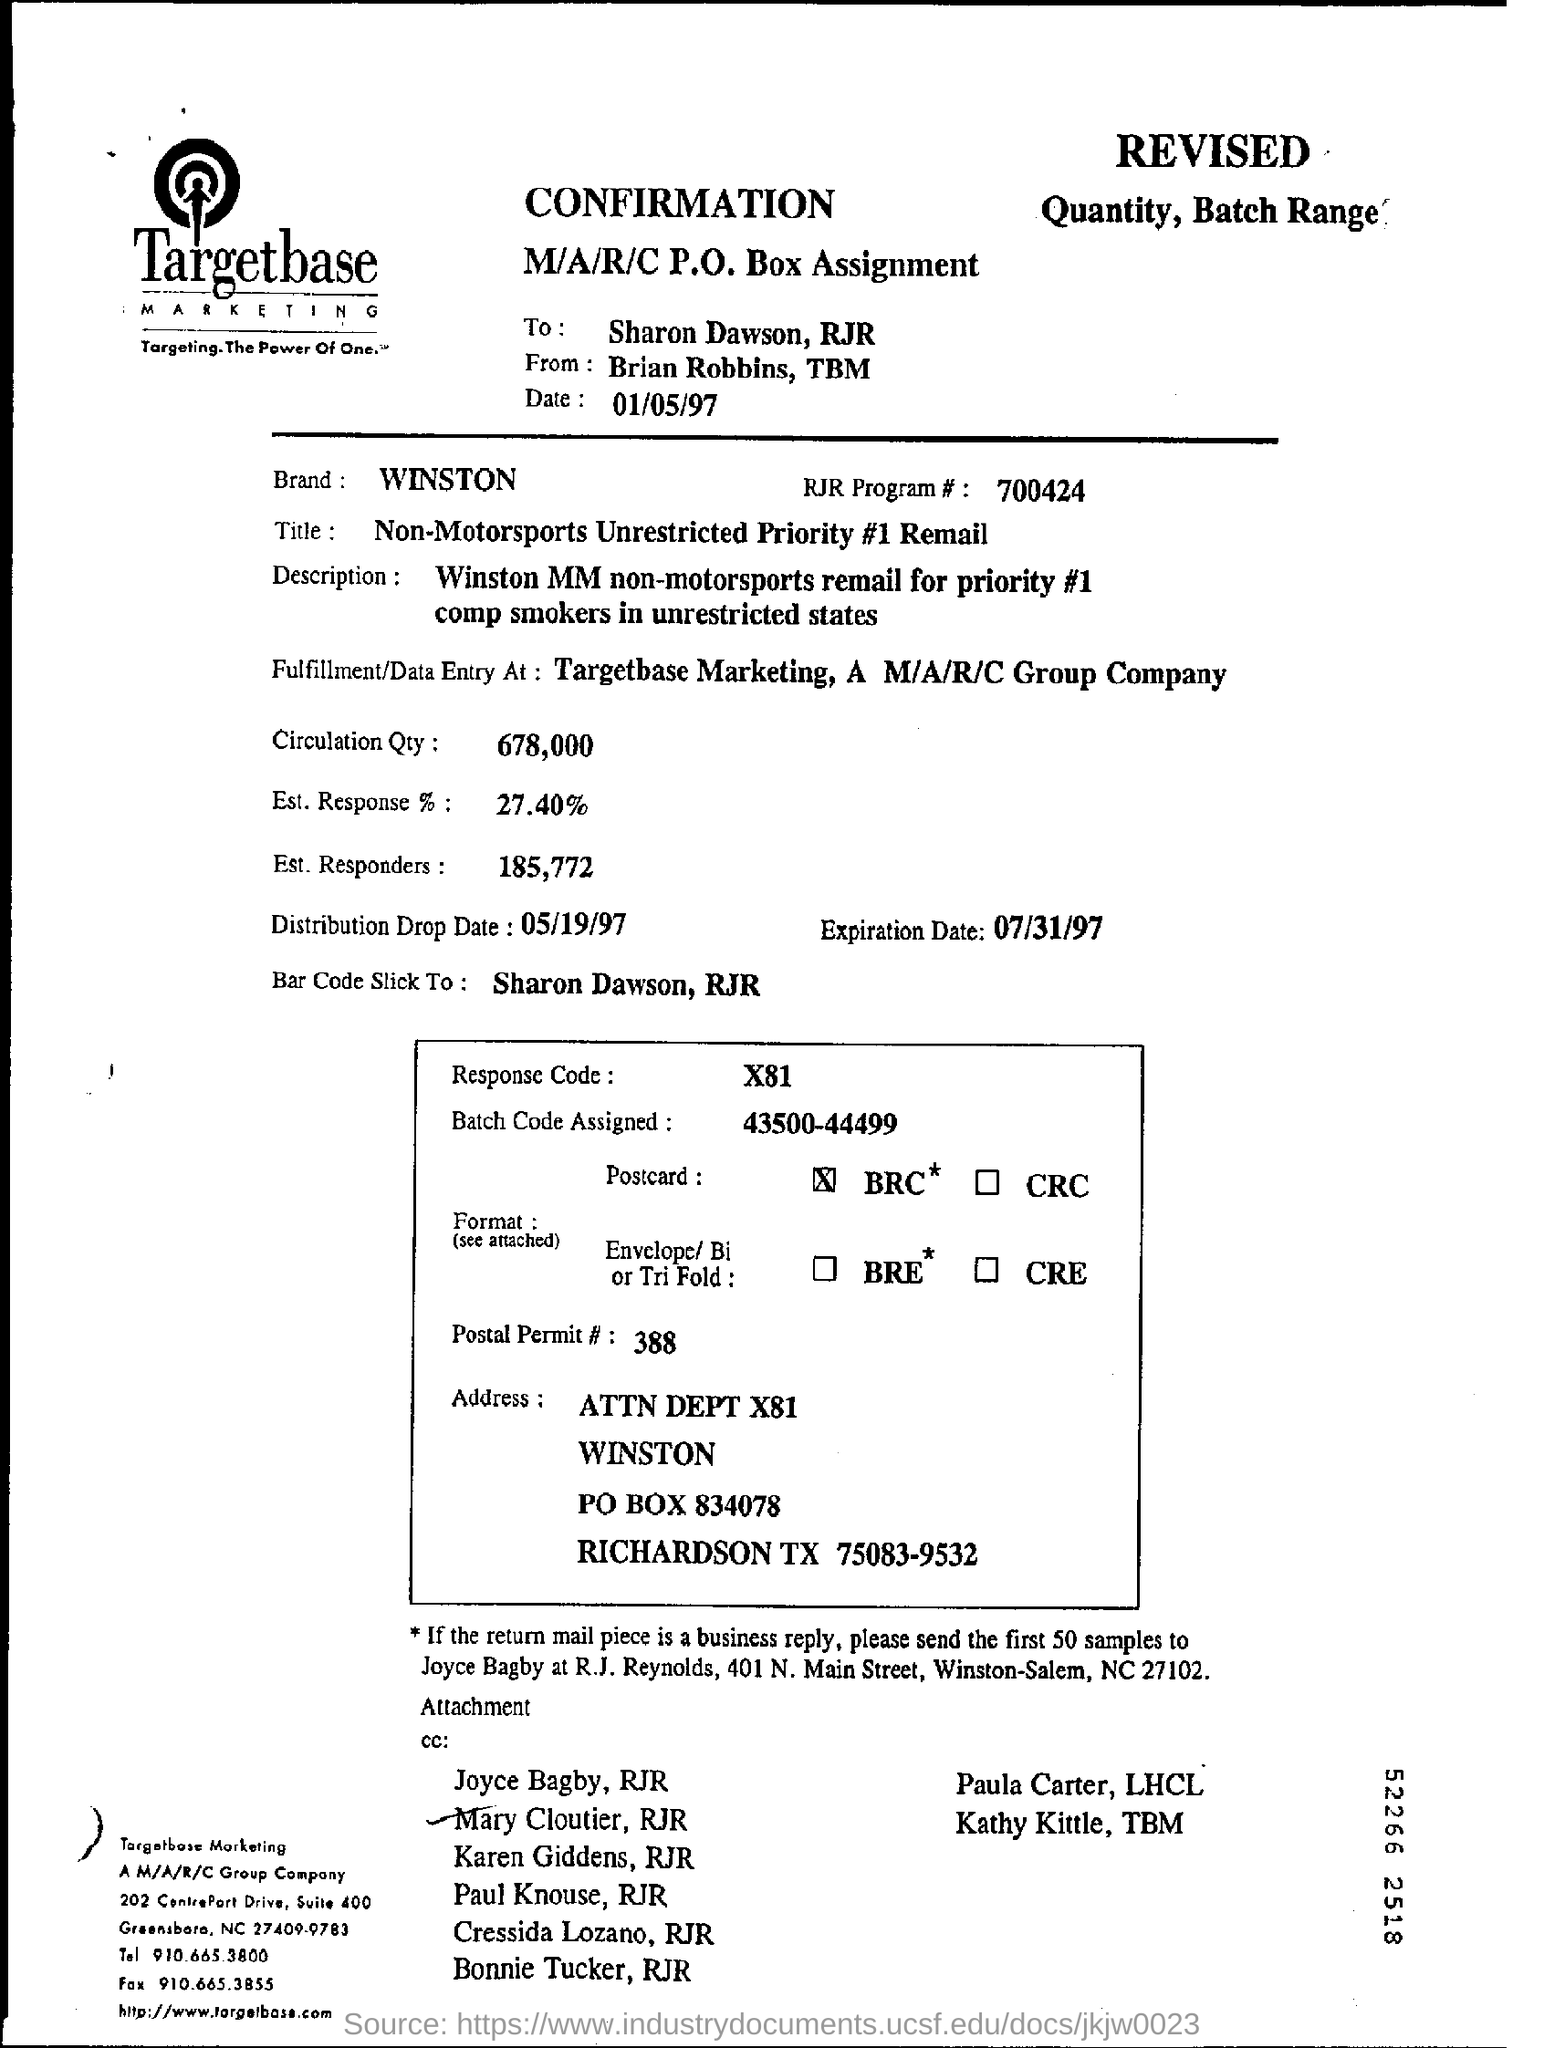Highlight a few significant elements in this photo. Based on the document, the estimated response rate is 27.40%. The expiration date mentioned in the document is 07/31/97. The circulation quantity, as specified in the document, is 678,000. The batch code assigned is 43500-444999. The brand mentioned in the document is WINSTON. 